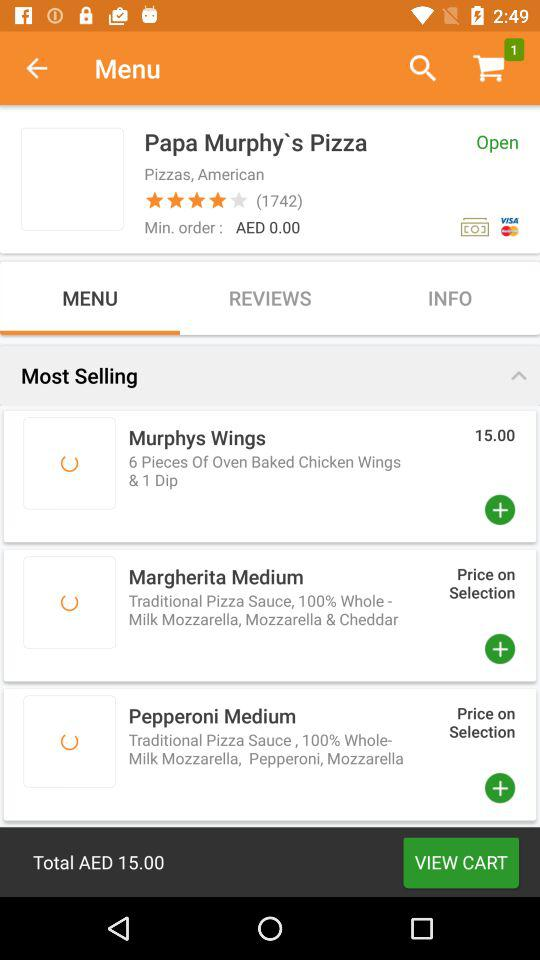What is the status of the "Papa Murphy's Pizza" store? The status of the "Papa Murphy's Pizza" store is "Open". 